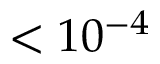<formula> <loc_0><loc_0><loc_500><loc_500>< 1 0 ^ { - 4 }</formula> 